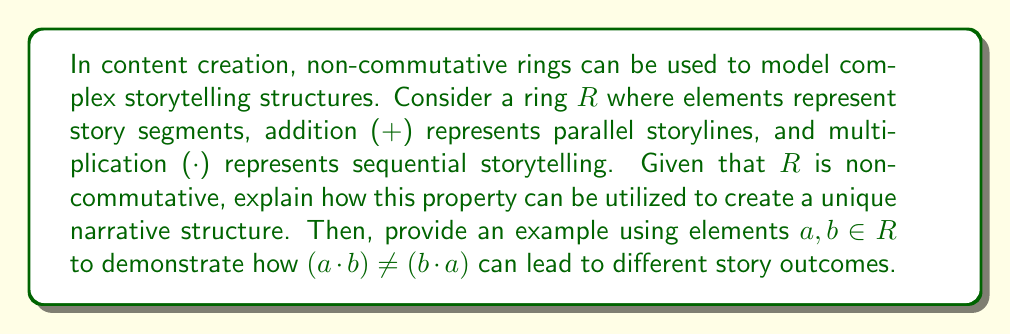Provide a solution to this math problem. To understand how non-commutative rings can be applied to content creation, let's break down the concept:

1. Ring Structure:
   - Elements of $R$ represent story segments
   - Addition ($+$) represents parallel storylines
   - Multiplication ($\cdot$) represents sequential storytelling

2. Non-commutativity:
   In a non-commutative ring, the order of multiplication matters. This means:
   $$(a \cdot b) \neq (b \cdot a)$$
   for some $a, b \in R$

3. Application to Storytelling:
   - The non-commutative property allows for the creation of branching narratives where the order of events significantly impacts the story outcome.
   - This can be used to create interactive stories, choose-your-own-adventure narratives, or complex plot structures with multiple timelines.

4. Example:
   Let $a$ and $b$ be two story segments in $R$.
   - $(a \cdot b)$ could represent a sequence where event $a$ happens before event $b$.
   - $(b \cdot a)$ would then represent a sequence where event $b$ happens before event $a$.

   The non-commutative property ensures that these two sequences lead to different outcomes, allowing for:
   - Cause-and-effect relationships
   - Character development based on the order of experiences
   - Multiple narrative paths depending on user choices

5. Unique Narrative Structure:
   By leveraging this non-commutative property, content creators can design:
   - Non-linear storytelling
   - Parallel universes or timelines
   - Interactive narratives where user choices matter
   - Complex plot structures with intertwining storylines

This approach allows for the creation of rich, multi-layered narratives that can engage audiences in novel ways, encouraging repeated consumption of content to explore different outcomes.
Answer: The non-commutative property of the ring $R$ in storytelling allows for the creation of branching narratives where the order of events significantly impacts the story outcome. For elements $a, b \in R$, $(a \cdot b) \neq (b \cdot a)$ can lead to different story outcomes by changing the sequence of events, affecting cause-and-effect relationships, character development, and overall plot progression. 